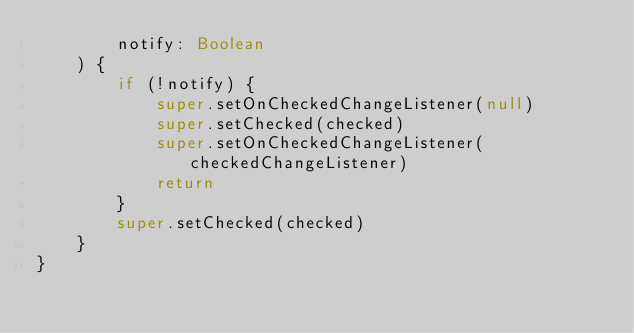<code> <loc_0><loc_0><loc_500><loc_500><_Kotlin_>        notify: Boolean
    ) {
        if (!notify) {
            super.setOnCheckedChangeListener(null)
            super.setChecked(checked)
            super.setOnCheckedChangeListener(checkedChangeListener)
            return
        }
        super.setChecked(checked)
    }
}</code> 